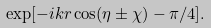Convert formula to latex. <formula><loc_0><loc_0><loc_500><loc_500>\exp [ - i k r \cos ( \eta \pm \chi ) - \pi / 4 ] .</formula> 